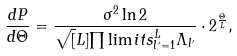<formula> <loc_0><loc_0><loc_500><loc_500>\frac { d P } { d \Theta } = \frac { \sigma ^ { 2 } \ln 2 } { \sqrt { [ } L ] { \prod \lim i t s _ { l ^ { \prime } = 1 } ^ { L } { \Lambda } _ { l ^ { \prime } } } } \cdot 2 ^ { \frac { \Theta } { L } } ,</formula> 